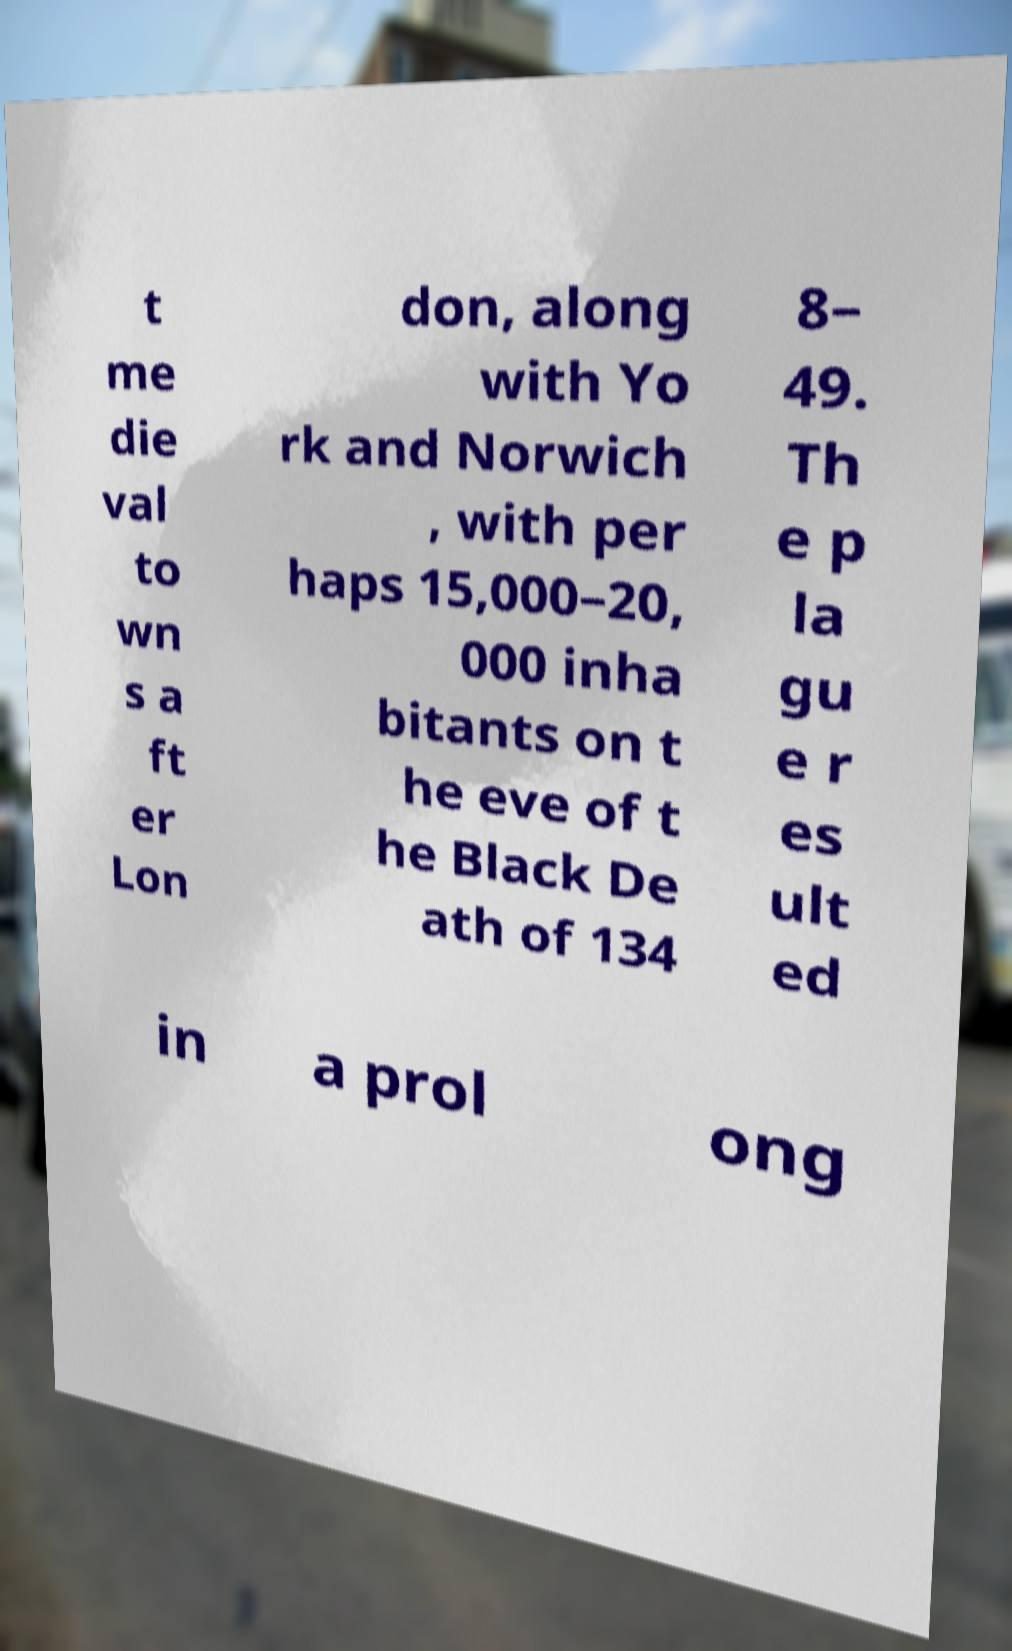I need the written content from this picture converted into text. Can you do that? t me die val to wn s a ft er Lon don, along with Yo rk and Norwich , with per haps 15,000–20, 000 inha bitants on t he eve of t he Black De ath of 134 8– 49. Th e p la gu e r es ult ed in a prol ong 